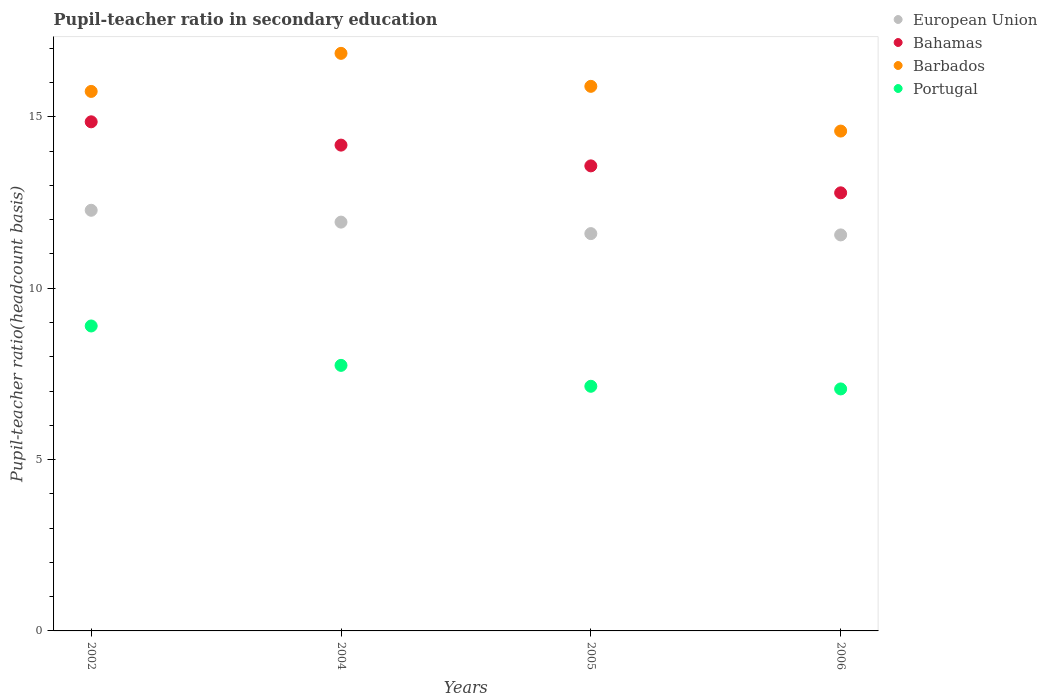What is the pupil-teacher ratio in secondary education in European Union in 2002?
Your answer should be very brief. 12.27. Across all years, what is the maximum pupil-teacher ratio in secondary education in Bahamas?
Provide a short and direct response. 14.85. Across all years, what is the minimum pupil-teacher ratio in secondary education in European Union?
Your answer should be compact. 11.55. In which year was the pupil-teacher ratio in secondary education in Barbados minimum?
Give a very brief answer. 2006. What is the total pupil-teacher ratio in secondary education in European Union in the graph?
Your response must be concise. 47.35. What is the difference between the pupil-teacher ratio in secondary education in European Union in 2002 and that in 2004?
Make the answer very short. 0.35. What is the difference between the pupil-teacher ratio in secondary education in Portugal in 2006 and the pupil-teacher ratio in secondary education in Bahamas in 2002?
Keep it short and to the point. -7.79. What is the average pupil-teacher ratio in secondary education in European Union per year?
Offer a terse response. 11.84. In the year 2002, what is the difference between the pupil-teacher ratio in secondary education in Portugal and pupil-teacher ratio in secondary education in European Union?
Provide a short and direct response. -3.38. In how many years, is the pupil-teacher ratio in secondary education in Portugal greater than 3?
Keep it short and to the point. 4. What is the ratio of the pupil-teacher ratio in secondary education in Barbados in 2002 to that in 2005?
Offer a very short reply. 0.99. Is the pupil-teacher ratio in secondary education in Barbados in 2002 less than that in 2005?
Provide a succinct answer. Yes. What is the difference between the highest and the second highest pupil-teacher ratio in secondary education in Portugal?
Your response must be concise. 1.15. What is the difference between the highest and the lowest pupil-teacher ratio in secondary education in Bahamas?
Offer a very short reply. 2.07. In how many years, is the pupil-teacher ratio in secondary education in Bahamas greater than the average pupil-teacher ratio in secondary education in Bahamas taken over all years?
Offer a terse response. 2. Is the sum of the pupil-teacher ratio in secondary education in Bahamas in 2002 and 2004 greater than the maximum pupil-teacher ratio in secondary education in European Union across all years?
Make the answer very short. Yes. Is the pupil-teacher ratio in secondary education in Bahamas strictly greater than the pupil-teacher ratio in secondary education in Portugal over the years?
Provide a short and direct response. Yes. Is the pupil-teacher ratio in secondary education in European Union strictly less than the pupil-teacher ratio in secondary education in Portugal over the years?
Give a very brief answer. No. What is the difference between two consecutive major ticks on the Y-axis?
Your response must be concise. 5. Are the values on the major ticks of Y-axis written in scientific E-notation?
Your answer should be very brief. No. Does the graph contain any zero values?
Provide a short and direct response. No. Where does the legend appear in the graph?
Give a very brief answer. Top right. What is the title of the graph?
Your answer should be very brief. Pupil-teacher ratio in secondary education. What is the label or title of the X-axis?
Your answer should be very brief. Years. What is the label or title of the Y-axis?
Offer a terse response. Pupil-teacher ratio(headcount basis). What is the Pupil-teacher ratio(headcount basis) in European Union in 2002?
Your response must be concise. 12.27. What is the Pupil-teacher ratio(headcount basis) in Bahamas in 2002?
Provide a succinct answer. 14.85. What is the Pupil-teacher ratio(headcount basis) in Barbados in 2002?
Provide a short and direct response. 15.74. What is the Pupil-teacher ratio(headcount basis) in Portugal in 2002?
Your response must be concise. 8.9. What is the Pupil-teacher ratio(headcount basis) of European Union in 2004?
Keep it short and to the point. 11.93. What is the Pupil-teacher ratio(headcount basis) in Bahamas in 2004?
Provide a succinct answer. 14.17. What is the Pupil-teacher ratio(headcount basis) of Barbados in 2004?
Offer a very short reply. 16.85. What is the Pupil-teacher ratio(headcount basis) in Portugal in 2004?
Keep it short and to the point. 7.75. What is the Pupil-teacher ratio(headcount basis) in European Union in 2005?
Give a very brief answer. 11.59. What is the Pupil-teacher ratio(headcount basis) in Bahamas in 2005?
Your response must be concise. 13.57. What is the Pupil-teacher ratio(headcount basis) in Barbados in 2005?
Keep it short and to the point. 15.89. What is the Pupil-teacher ratio(headcount basis) of Portugal in 2005?
Provide a succinct answer. 7.14. What is the Pupil-teacher ratio(headcount basis) of European Union in 2006?
Your response must be concise. 11.55. What is the Pupil-teacher ratio(headcount basis) in Bahamas in 2006?
Keep it short and to the point. 12.78. What is the Pupil-teacher ratio(headcount basis) of Barbados in 2006?
Your response must be concise. 14.58. What is the Pupil-teacher ratio(headcount basis) of Portugal in 2006?
Provide a succinct answer. 7.06. Across all years, what is the maximum Pupil-teacher ratio(headcount basis) of European Union?
Your answer should be compact. 12.27. Across all years, what is the maximum Pupil-teacher ratio(headcount basis) in Bahamas?
Offer a very short reply. 14.85. Across all years, what is the maximum Pupil-teacher ratio(headcount basis) in Barbados?
Offer a very short reply. 16.85. Across all years, what is the maximum Pupil-teacher ratio(headcount basis) of Portugal?
Your answer should be compact. 8.9. Across all years, what is the minimum Pupil-teacher ratio(headcount basis) of European Union?
Offer a very short reply. 11.55. Across all years, what is the minimum Pupil-teacher ratio(headcount basis) of Bahamas?
Ensure brevity in your answer.  12.78. Across all years, what is the minimum Pupil-teacher ratio(headcount basis) in Barbados?
Provide a succinct answer. 14.58. Across all years, what is the minimum Pupil-teacher ratio(headcount basis) in Portugal?
Your answer should be compact. 7.06. What is the total Pupil-teacher ratio(headcount basis) in European Union in the graph?
Your answer should be very brief. 47.35. What is the total Pupil-teacher ratio(headcount basis) of Bahamas in the graph?
Provide a succinct answer. 55.38. What is the total Pupil-teacher ratio(headcount basis) in Barbados in the graph?
Ensure brevity in your answer.  63.06. What is the total Pupil-teacher ratio(headcount basis) of Portugal in the graph?
Provide a succinct answer. 30.84. What is the difference between the Pupil-teacher ratio(headcount basis) in European Union in 2002 and that in 2004?
Make the answer very short. 0.35. What is the difference between the Pupil-teacher ratio(headcount basis) of Bahamas in 2002 and that in 2004?
Your response must be concise. 0.68. What is the difference between the Pupil-teacher ratio(headcount basis) in Barbados in 2002 and that in 2004?
Provide a short and direct response. -1.11. What is the difference between the Pupil-teacher ratio(headcount basis) of Portugal in 2002 and that in 2004?
Offer a very short reply. 1.15. What is the difference between the Pupil-teacher ratio(headcount basis) in European Union in 2002 and that in 2005?
Your answer should be compact. 0.68. What is the difference between the Pupil-teacher ratio(headcount basis) of Bahamas in 2002 and that in 2005?
Your answer should be compact. 1.29. What is the difference between the Pupil-teacher ratio(headcount basis) in Barbados in 2002 and that in 2005?
Keep it short and to the point. -0.15. What is the difference between the Pupil-teacher ratio(headcount basis) of Portugal in 2002 and that in 2005?
Your answer should be very brief. 1.76. What is the difference between the Pupil-teacher ratio(headcount basis) in European Union in 2002 and that in 2006?
Provide a succinct answer. 0.72. What is the difference between the Pupil-teacher ratio(headcount basis) in Bahamas in 2002 and that in 2006?
Ensure brevity in your answer.  2.07. What is the difference between the Pupil-teacher ratio(headcount basis) in Barbados in 2002 and that in 2006?
Provide a succinct answer. 1.16. What is the difference between the Pupil-teacher ratio(headcount basis) of Portugal in 2002 and that in 2006?
Your answer should be compact. 1.84. What is the difference between the Pupil-teacher ratio(headcount basis) in European Union in 2004 and that in 2005?
Offer a very short reply. 0.34. What is the difference between the Pupil-teacher ratio(headcount basis) of Bahamas in 2004 and that in 2005?
Provide a succinct answer. 0.61. What is the difference between the Pupil-teacher ratio(headcount basis) in Barbados in 2004 and that in 2005?
Ensure brevity in your answer.  0.96. What is the difference between the Pupil-teacher ratio(headcount basis) of Portugal in 2004 and that in 2005?
Provide a succinct answer. 0.61. What is the difference between the Pupil-teacher ratio(headcount basis) of European Union in 2004 and that in 2006?
Ensure brevity in your answer.  0.37. What is the difference between the Pupil-teacher ratio(headcount basis) in Bahamas in 2004 and that in 2006?
Your answer should be very brief. 1.39. What is the difference between the Pupil-teacher ratio(headcount basis) in Barbados in 2004 and that in 2006?
Keep it short and to the point. 2.27. What is the difference between the Pupil-teacher ratio(headcount basis) of Portugal in 2004 and that in 2006?
Ensure brevity in your answer.  0.69. What is the difference between the Pupil-teacher ratio(headcount basis) of European Union in 2005 and that in 2006?
Your answer should be very brief. 0.04. What is the difference between the Pupil-teacher ratio(headcount basis) of Bahamas in 2005 and that in 2006?
Offer a terse response. 0.79. What is the difference between the Pupil-teacher ratio(headcount basis) of Barbados in 2005 and that in 2006?
Keep it short and to the point. 1.3. What is the difference between the Pupil-teacher ratio(headcount basis) of Portugal in 2005 and that in 2006?
Provide a succinct answer. 0.08. What is the difference between the Pupil-teacher ratio(headcount basis) of European Union in 2002 and the Pupil-teacher ratio(headcount basis) of Bahamas in 2004?
Give a very brief answer. -1.9. What is the difference between the Pupil-teacher ratio(headcount basis) of European Union in 2002 and the Pupil-teacher ratio(headcount basis) of Barbados in 2004?
Provide a short and direct response. -4.58. What is the difference between the Pupil-teacher ratio(headcount basis) of European Union in 2002 and the Pupil-teacher ratio(headcount basis) of Portugal in 2004?
Make the answer very short. 4.53. What is the difference between the Pupil-teacher ratio(headcount basis) of Bahamas in 2002 and the Pupil-teacher ratio(headcount basis) of Barbados in 2004?
Ensure brevity in your answer.  -2. What is the difference between the Pupil-teacher ratio(headcount basis) in Bahamas in 2002 and the Pupil-teacher ratio(headcount basis) in Portugal in 2004?
Ensure brevity in your answer.  7.11. What is the difference between the Pupil-teacher ratio(headcount basis) of Barbados in 2002 and the Pupil-teacher ratio(headcount basis) of Portugal in 2004?
Your answer should be compact. 7.99. What is the difference between the Pupil-teacher ratio(headcount basis) of European Union in 2002 and the Pupil-teacher ratio(headcount basis) of Bahamas in 2005?
Keep it short and to the point. -1.3. What is the difference between the Pupil-teacher ratio(headcount basis) in European Union in 2002 and the Pupil-teacher ratio(headcount basis) in Barbados in 2005?
Make the answer very short. -3.62. What is the difference between the Pupil-teacher ratio(headcount basis) of European Union in 2002 and the Pupil-teacher ratio(headcount basis) of Portugal in 2005?
Offer a terse response. 5.14. What is the difference between the Pupil-teacher ratio(headcount basis) of Bahamas in 2002 and the Pupil-teacher ratio(headcount basis) of Barbados in 2005?
Ensure brevity in your answer.  -1.03. What is the difference between the Pupil-teacher ratio(headcount basis) in Bahamas in 2002 and the Pupil-teacher ratio(headcount basis) in Portugal in 2005?
Make the answer very short. 7.72. What is the difference between the Pupil-teacher ratio(headcount basis) of Barbados in 2002 and the Pupil-teacher ratio(headcount basis) of Portugal in 2005?
Make the answer very short. 8.6. What is the difference between the Pupil-teacher ratio(headcount basis) of European Union in 2002 and the Pupil-teacher ratio(headcount basis) of Bahamas in 2006?
Make the answer very short. -0.51. What is the difference between the Pupil-teacher ratio(headcount basis) in European Union in 2002 and the Pupil-teacher ratio(headcount basis) in Barbados in 2006?
Give a very brief answer. -2.31. What is the difference between the Pupil-teacher ratio(headcount basis) in European Union in 2002 and the Pupil-teacher ratio(headcount basis) in Portugal in 2006?
Offer a very short reply. 5.21. What is the difference between the Pupil-teacher ratio(headcount basis) in Bahamas in 2002 and the Pupil-teacher ratio(headcount basis) in Barbados in 2006?
Make the answer very short. 0.27. What is the difference between the Pupil-teacher ratio(headcount basis) of Bahamas in 2002 and the Pupil-teacher ratio(headcount basis) of Portugal in 2006?
Give a very brief answer. 7.79. What is the difference between the Pupil-teacher ratio(headcount basis) in Barbados in 2002 and the Pupil-teacher ratio(headcount basis) in Portugal in 2006?
Keep it short and to the point. 8.68. What is the difference between the Pupil-teacher ratio(headcount basis) in European Union in 2004 and the Pupil-teacher ratio(headcount basis) in Bahamas in 2005?
Provide a succinct answer. -1.64. What is the difference between the Pupil-teacher ratio(headcount basis) of European Union in 2004 and the Pupil-teacher ratio(headcount basis) of Barbados in 2005?
Provide a short and direct response. -3.96. What is the difference between the Pupil-teacher ratio(headcount basis) in European Union in 2004 and the Pupil-teacher ratio(headcount basis) in Portugal in 2005?
Keep it short and to the point. 4.79. What is the difference between the Pupil-teacher ratio(headcount basis) in Bahamas in 2004 and the Pupil-teacher ratio(headcount basis) in Barbados in 2005?
Provide a short and direct response. -1.71. What is the difference between the Pupil-teacher ratio(headcount basis) of Bahamas in 2004 and the Pupil-teacher ratio(headcount basis) of Portugal in 2005?
Keep it short and to the point. 7.04. What is the difference between the Pupil-teacher ratio(headcount basis) of Barbados in 2004 and the Pupil-teacher ratio(headcount basis) of Portugal in 2005?
Your answer should be compact. 9.71. What is the difference between the Pupil-teacher ratio(headcount basis) of European Union in 2004 and the Pupil-teacher ratio(headcount basis) of Bahamas in 2006?
Give a very brief answer. -0.85. What is the difference between the Pupil-teacher ratio(headcount basis) in European Union in 2004 and the Pupil-teacher ratio(headcount basis) in Barbados in 2006?
Offer a terse response. -2.66. What is the difference between the Pupil-teacher ratio(headcount basis) of European Union in 2004 and the Pupil-teacher ratio(headcount basis) of Portugal in 2006?
Provide a short and direct response. 4.87. What is the difference between the Pupil-teacher ratio(headcount basis) in Bahamas in 2004 and the Pupil-teacher ratio(headcount basis) in Barbados in 2006?
Provide a succinct answer. -0.41. What is the difference between the Pupil-teacher ratio(headcount basis) of Bahamas in 2004 and the Pupil-teacher ratio(headcount basis) of Portugal in 2006?
Ensure brevity in your answer.  7.11. What is the difference between the Pupil-teacher ratio(headcount basis) in Barbados in 2004 and the Pupil-teacher ratio(headcount basis) in Portugal in 2006?
Your response must be concise. 9.79. What is the difference between the Pupil-teacher ratio(headcount basis) in European Union in 2005 and the Pupil-teacher ratio(headcount basis) in Bahamas in 2006?
Ensure brevity in your answer.  -1.19. What is the difference between the Pupil-teacher ratio(headcount basis) of European Union in 2005 and the Pupil-teacher ratio(headcount basis) of Barbados in 2006?
Your answer should be very brief. -2.99. What is the difference between the Pupil-teacher ratio(headcount basis) of European Union in 2005 and the Pupil-teacher ratio(headcount basis) of Portugal in 2006?
Your answer should be very brief. 4.53. What is the difference between the Pupil-teacher ratio(headcount basis) in Bahamas in 2005 and the Pupil-teacher ratio(headcount basis) in Barbados in 2006?
Keep it short and to the point. -1.02. What is the difference between the Pupil-teacher ratio(headcount basis) in Bahamas in 2005 and the Pupil-teacher ratio(headcount basis) in Portugal in 2006?
Offer a very short reply. 6.51. What is the difference between the Pupil-teacher ratio(headcount basis) in Barbados in 2005 and the Pupil-teacher ratio(headcount basis) in Portugal in 2006?
Ensure brevity in your answer.  8.83. What is the average Pupil-teacher ratio(headcount basis) in European Union per year?
Offer a very short reply. 11.84. What is the average Pupil-teacher ratio(headcount basis) in Bahamas per year?
Offer a terse response. 13.84. What is the average Pupil-teacher ratio(headcount basis) of Barbados per year?
Your answer should be very brief. 15.77. What is the average Pupil-teacher ratio(headcount basis) of Portugal per year?
Ensure brevity in your answer.  7.71. In the year 2002, what is the difference between the Pupil-teacher ratio(headcount basis) in European Union and Pupil-teacher ratio(headcount basis) in Bahamas?
Your response must be concise. -2.58. In the year 2002, what is the difference between the Pupil-teacher ratio(headcount basis) in European Union and Pupil-teacher ratio(headcount basis) in Barbados?
Make the answer very short. -3.47. In the year 2002, what is the difference between the Pupil-teacher ratio(headcount basis) of European Union and Pupil-teacher ratio(headcount basis) of Portugal?
Make the answer very short. 3.38. In the year 2002, what is the difference between the Pupil-teacher ratio(headcount basis) in Bahamas and Pupil-teacher ratio(headcount basis) in Barbados?
Make the answer very short. -0.89. In the year 2002, what is the difference between the Pupil-teacher ratio(headcount basis) in Bahamas and Pupil-teacher ratio(headcount basis) in Portugal?
Ensure brevity in your answer.  5.96. In the year 2002, what is the difference between the Pupil-teacher ratio(headcount basis) of Barbados and Pupil-teacher ratio(headcount basis) of Portugal?
Your answer should be very brief. 6.84. In the year 2004, what is the difference between the Pupil-teacher ratio(headcount basis) of European Union and Pupil-teacher ratio(headcount basis) of Bahamas?
Provide a short and direct response. -2.25. In the year 2004, what is the difference between the Pupil-teacher ratio(headcount basis) of European Union and Pupil-teacher ratio(headcount basis) of Barbados?
Offer a very short reply. -4.92. In the year 2004, what is the difference between the Pupil-teacher ratio(headcount basis) in European Union and Pupil-teacher ratio(headcount basis) in Portugal?
Make the answer very short. 4.18. In the year 2004, what is the difference between the Pupil-teacher ratio(headcount basis) in Bahamas and Pupil-teacher ratio(headcount basis) in Barbados?
Provide a short and direct response. -2.68. In the year 2004, what is the difference between the Pupil-teacher ratio(headcount basis) in Bahamas and Pupil-teacher ratio(headcount basis) in Portugal?
Offer a very short reply. 6.43. In the year 2004, what is the difference between the Pupil-teacher ratio(headcount basis) in Barbados and Pupil-teacher ratio(headcount basis) in Portugal?
Keep it short and to the point. 9.1. In the year 2005, what is the difference between the Pupil-teacher ratio(headcount basis) in European Union and Pupil-teacher ratio(headcount basis) in Bahamas?
Provide a short and direct response. -1.98. In the year 2005, what is the difference between the Pupil-teacher ratio(headcount basis) in European Union and Pupil-teacher ratio(headcount basis) in Barbados?
Offer a terse response. -4.3. In the year 2005, what is the difference between the Pupil-teacher ratio(headcount basis) in European Union and Pupil-teacher ratio(headcount basis) in Portugal?
Your answer should be compact. 4.45. In the year 2005, what is the difference between the Pupil-teacher ratio(headcount basis) of Bahamas and Pupil-teacher ratio(headcount basis) of Barbados?
Your answer should be compact. -2.32. In the year 2005, what is the difference between the Pupil-teacher ratio(headcount basis) in Bahamas and Pupil-teacher ratio(headcount basis) in Portugal?
Provide a succinct answer. 6.43. In the year 2005, what is the difference between the Pupil-teacher ratio(headcount basis) of Barbados and Pupil-teacher ratio(headcount basis) of Portugal?
Ensure brevity in your answer.  8.75. In the year 2006, what is the difference between the Pupil-teacher ratio(headcount basis) in European Union and Pupil-teacher ratio(headcount basis) in Bahamas?
Your answer should be very brief. -1.23. In the year 2006, what is the difference between the Pupil-teacher ratio(headcount basis) in European Union and Pupil-teacher ratio(headcount basis) in Barbados?
Make the answer very short. -3.03. In the year 2006, what is the difference between the Pupil-teacher ratio(headcount basis) of European Union and Pupil-teacher ratio(headcount basis) of Portugal?
Provide a short and direct response. 4.49. In the year 2006, what is the difference between the Pupil-teacher ratio(headcount basis) of Bahamas and Pupil-teacher ratio(headcount basis) of Barbados?
Ensure brevity in your answer.  -1.8. In the year 2006, what is the difference between the Pupil-teacher ratio(headcount basis) in Bahamas and Pupil-teacher ratio(headcount basis) in Portugal?
Your answer should be compact. 5.72. In the year 2006, what is the difference between the Pupil-teacher ratio(headcount basis) of Barbados and Pupil-teacher ratio(headcount basis) of Portugal?
Keep it short and to the point. 7.52. What is the ratio of the Pupil-teacher ratio(headcount basis) in Bahamas in 2002 to that in 2004?
Offer a terse response. 1.05. What is the ratio of the Pupil-teacher ratio(headcount basis) in Barbados in 2002 to that in 2004?
Offer a terse response. 0.93. What is the ratio of the Pupil-teacher ratio(headcount basis) in Portugal in 2002 to that in 2004?
Offer a terse response. 1.15. What is the ratio of the Pupil-teacher ratio(headcount basis) in European Union in 2002 to that in 2005?
Offer a terse response. 1.06. What is the ratio of the Pupil-teacher ratio(headcount basis) of Bahamas in 2002 to that in 2005?
Keep it short and to the point. 1.09. What is the ratio of the Pupil-teacher ratio(headcount basis) of Barbados in 2002 to that in 2005?
Your answer should be very brief. 0.99. What is the ratio of the Pupil-teacher ratio(headcount basis) in Portugal in 2002 to that in 2005?
Provide a short and direct response. 1.25. What is the ratio of the Pupil-teacher ratio(headcount basis) in European Union in 2002 to that in 2006?
Offer a very short reply. 1.06. What is the ratio of the Pupil-teacher ratio(headcount basis) of Bahamas in 2002 to that in 2006?
Ensure brevity in your answer.  1.16. What is the ratio of the Pupil-teacher ratio(headcount basis) of Barbados in 2002 to that in 2006?
Your answer should be very brief. 1.08. What is the ratio of the Pupil-teacher ratio(headcount basis) of Portugal in 2002 to that in 2006?
Provide a succinct answer. 1.26. What is the ratio of the Pupil-teacher ratio(headcount basis) of European Union in 2004 to that in 2005?
Your answer should be compact. 1.03. What is the ratio of the Pupil-teacher ratio(headcount basis) in Bahamas in 2004 to that in 2005?
Ensure brevity in your answer.  1.04. What is the ratio of the Pupil-teacher ratio(headcount basis) of Barbados in 2004 to that in 2005?
Your answer should be compact. 1.06. What is the ratio of the Pupil-teacher ratio(headcount basis) in Portugal in 2004 to that in 2005?
Offer a very short reply. 1.09. What is the ratio of the Pupil-teacher ratio(headcount basis) in European Union in 2004 to that in 2006?
Provide a short and direct response. 1.03. What is the ratio of the Pupil-teacher ratio(headcount basis) of Bahamas in 2004 to that in 2006?
Make the answer very short. 1.11. What is the ratio of the Pupil-teacher ratio(headcount basis) of Barbados in 2004 to that in 2006?
Your answer should be very brief. 1.16. What is the ratio of the Pupil-teacher ratio(headcount basis) in Portugal in 2004 to that in 2006?
Keep it short and to the point. 1.1. What is the ratio of the Pupil-teacher ratio(headcount basis) in European Union in 2005 to that in 2006?
Offer a terse response. 1. What is the ratio of the Pupil-teacher ratio(headcount basis) of Bahamas in 2005 to that in 2006?
Make the answer very short. 1.06. What is the ratio of the Pupil-teacher ratio(headcount basis) in Barbados in 2005 to that in 2006?
Provide a succinct answer. 1.09. What is the ratio of the Pupil-teacher ratio(headcount basis) of Portugal in 2005 to that in 2006?
Keep it short and to the point. 1.01. What is the difference between the highest and the second highest Pupil-teacher ratio(headcount basis) of European Union?
Your answer should be compact. 0.35. What is the difference between the highest and the second highest Pupil-teacher ratio(headcount basis) of Bahamas?
Offer a very short reply. 0.68. What is the difference between the highest and the second highest Pupil-teacher ratio(headcount basis) of Barbados?
Your response must be concise. 0.96. What is the difference between the highest and the second highest Pupil-teacher ratio(headcount basis) in Portugal?
Offer a very short reply. 1.15. What is the difference between the highest and the lowest Pupil-teacher ratio(headcount basis) in European Union?
Ensure brevity in your answer.  0.72. What is the difference between the highest and the lowest Pupil-teacher ratio(headcount basis) in Bahamas?
Your answer should be very brief. 2.07. What is the difference between the highest and the lowest Pupil-teacher ratio(headcount basis) in Barbados?
Your answer should be very brief. 2.27. What is the difference between the highest and the lowest Pupil-teacher ratio(headcount basis) in Portugal?
Offer a very short reply. 1.84. 